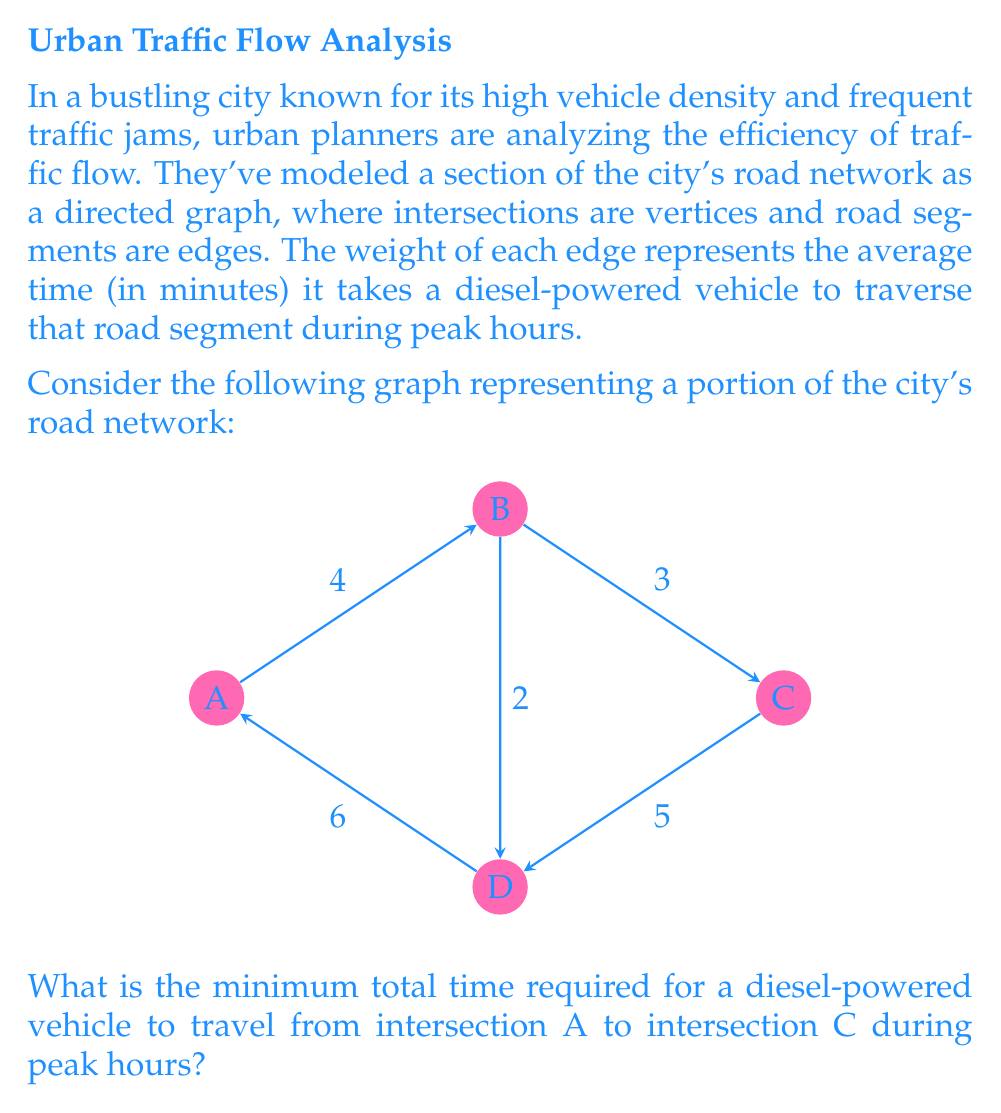Teach me how to tackle this problem. To solve this problem, we need to find the shortest path from vertex A to vertex C in the given weighted directed graph. We can use Dijkstra's algorithm to find the shortest path.

Step 1: Initialize distances
Set distance to A as 0 and all other vertices as infinity.
$d(A) = 0$, $d(B) = \infty$, $d(C) = \infty$, $d(D) = \infty$

Step 2: Update distances for neighbors of A
$d(B) = \min(\infty, 0 + 4) = 4$
$d(D) = \min(\infty, 0 + 6) = 6$

Step 3: Select vertex with minimum distance (B)
Update distances for neighbors of B
$d(C) = \min(\infty, 4 + 3) = 7$
$d(D) = \min(6, 4 + 2) = 6$

Step 4: Select vertex with minimum distance (D)
No updates needed as D has no unvisited neighbors

Step 5: Select vertex C
This is our target vertex, so we can stop here.

The shortest path from A to C is A → B → C with a total time of 7 minutes.

This result shows that even for diesel-powered vehicles, which are often criticized for their environmental impact, efficient route planning can minimize travel time and potentially reduce emissions in high-density urban areas.
Answer: 7 minutes 